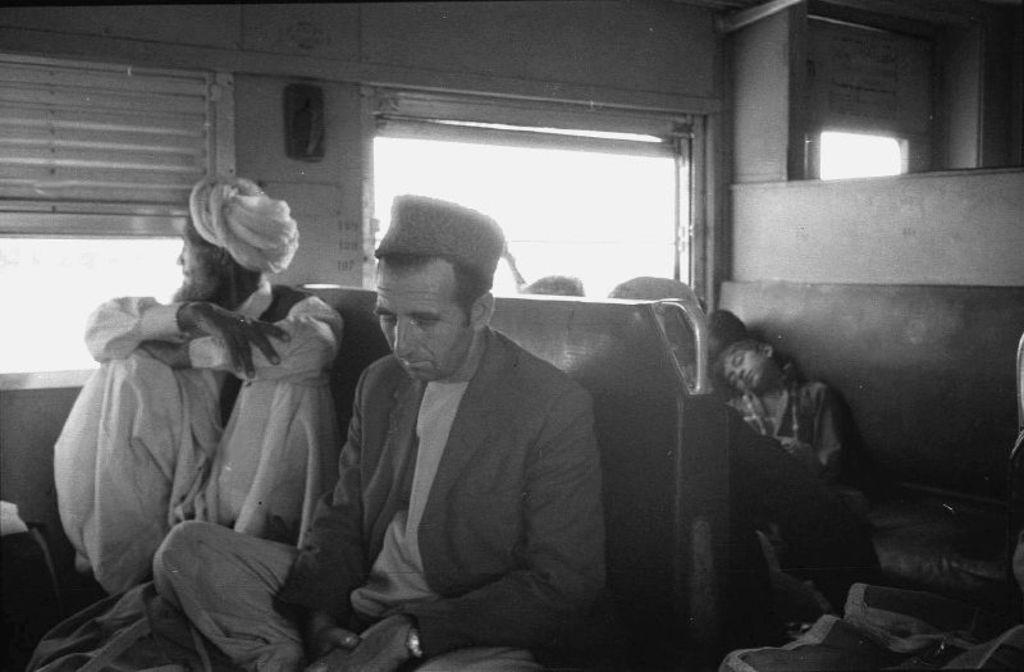Describe this image in one or two sentences. It is a black and white image, it seems like the pictures is captured inside a train and there are passengers sitting on the seats, behind the passengers there are windows. 